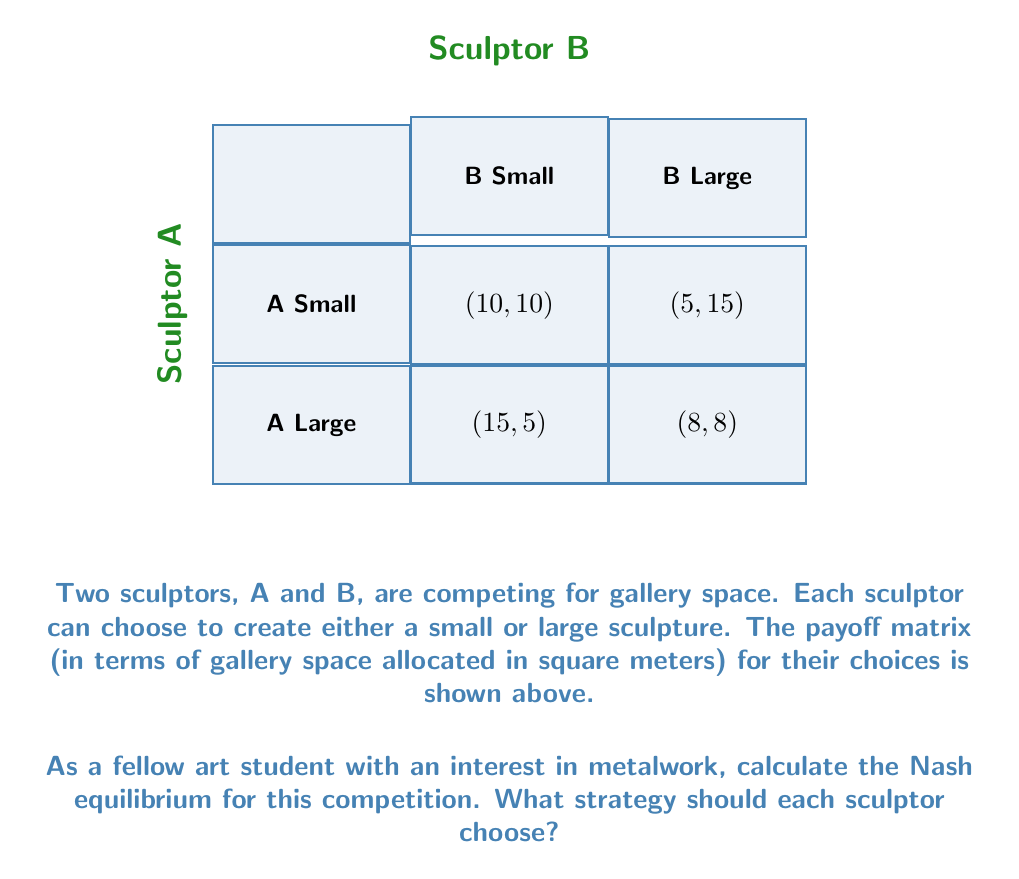Teach me how to tackle this problem. To find the Nash equilibrium, we need to determine the best response for each sculptor given the other's strategy. Let's analyze this step-by-step:

1. For Sculptor A:
   - If B chooses Small:
     - A choosing Small gives 10
     - A choosing Large gives 15
     So, A's best response is Large
   - If B chooses Large:
     - A choosing Small gives 5
     - A choosing Large gives 8
     So, A's best response is Large

2. For Sculptor B:
   - If A chooses Small:
     - B choosing Small gives 10
     - B choosing Large gives 15
     So, B's best response is Large
   - If A chooses Large:
     - B choosing Small gives 5
     - B choosing Large gives 8
     So, B's best response is Large

3. Nash equilibrium occurs when both sculptors are playing their best responses simultaneously.

4. From our analysis, we can see that regardless of what the other sculptor does, both A and B always prefer to choose Large.

5. Therefore, the Nash equilibrium is (Large, Large), resulting in a payoff of (8, 8).

This equilibrium reflects the competitive nature of the art world, where artists often feel pressured to create larger, more impressive pieces to stand out, even if it might lead to a suboptimal outcome for both parties compared to if they had both chosen Small (10, 10).
Answer: Nash equilibrium: (Large, Large) 